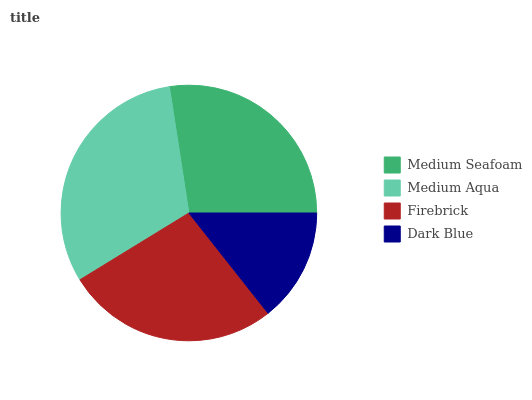Is Dark Blue the minimum?
Answer yes or no. Yes. Is Medium Aqua the maximum?
Answer yes or no. Yes. Is Firebrick the minimum?
Answer yes or no. No. Is Firebrick the maximum?
Answer yes or no. No. Is Medium Aqua greater than Firebrick?
Answer yes or no. Yes. Is Firebrick less than Medium Aqua?
Answer yes or no. Yes. Is Firebrick greater than Medium Aqua?
Answer yes or no. No. Is Medium Aqua less than Firebrick?
Answer yes or no. No. Is Medium Seafoam the high median?
Answer yes or no. Yes. Is Firebrick the low median?
Answer yes or no. Yes. Is Medium Aqua the high median?
Answer yes or no. No. Is Dark Blue the low median?
Answer yes or no. No. 